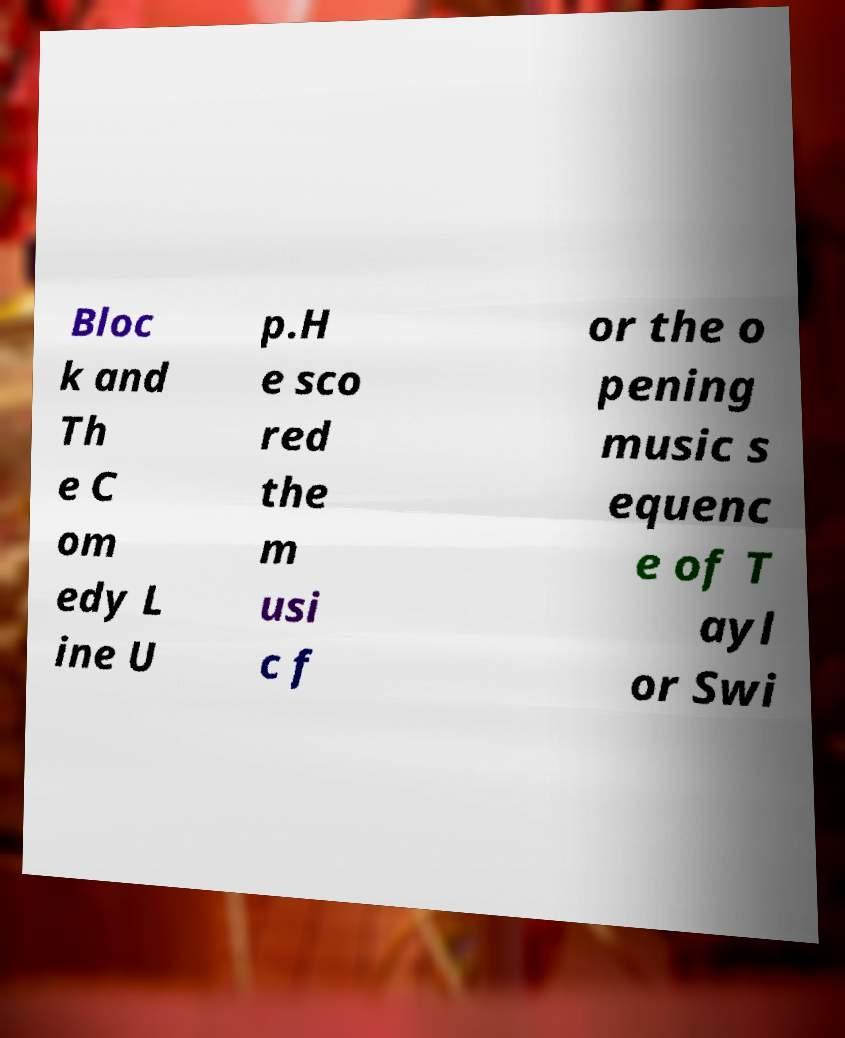Please read and relay the text visible in this image. What does it say? Bloc k and Th e C om edy L ine U p.H e sco red the m usi c f or the o pening music s equenc e of T ayl or Swi 